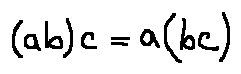Convert formula to latex. <formula><loc_0><loc_0><loc_500><loc_500>( a b ) c = a ( b c )</formula> 